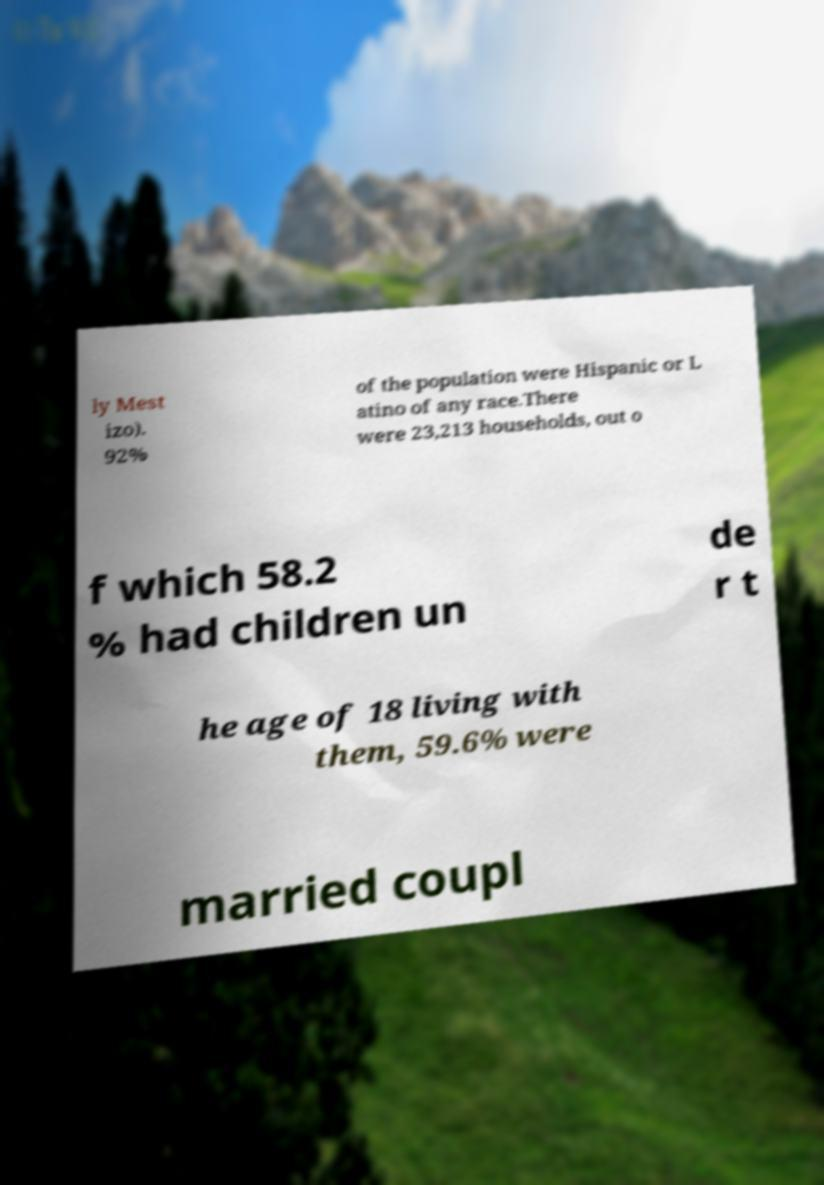Please read and relay the text visible in this image. What does it say? ly Mest izo). 92% of the population were Hispanic or L atino of any race.There were 23,213 households, out o f which 58.2 % had children un de r t he age of 18 living with them, 59.6% were married coupl 